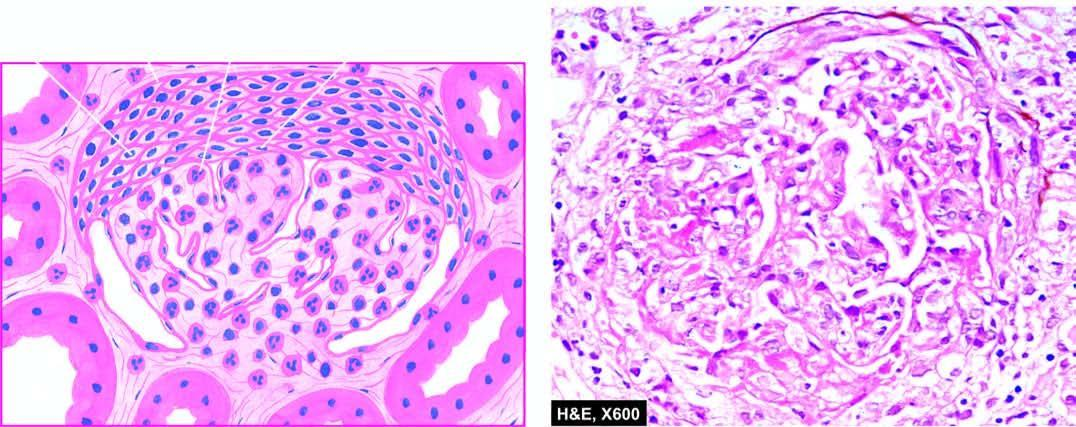re there crescents in bowman 's space forming adhesions between the glomerular tuft and bowman 's capsule?
Answer the question using a single word or phrase. Yes 